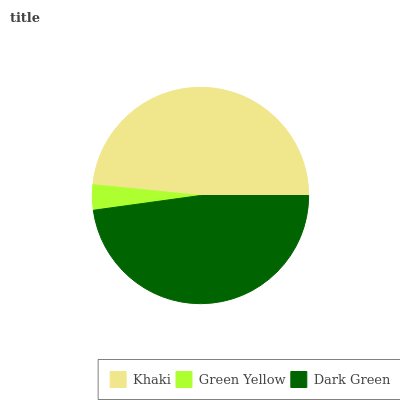Is Green Yellow the minimum?
Answer yes or no. Yes. Is Khaki the maximum?
Answer yes or no. Yes. Is Dark Green the minimum?
Answer yes or no. No. Is Dark Green the maximum?
Answer yes or no. No. Is Dark Green greater than Green Yellow?
Answer yes or no. Yes. Is Green Yellow less than Dark Green?
Answer yes or no. Yes. Is Green Yellow greater than Dark Green?
Answer yes or no. No. Is Dark Green less than Green Yellow?
Answer yes or no. No. Is Dark Green the high median?
Answer yes or no. Yes. Is Dark Green the low median?
Answer yes or no. Yes. Is Khaki the high median?
Answer yes or no. No. Is Green Yellow the low median?
Answer yes or no. No. 